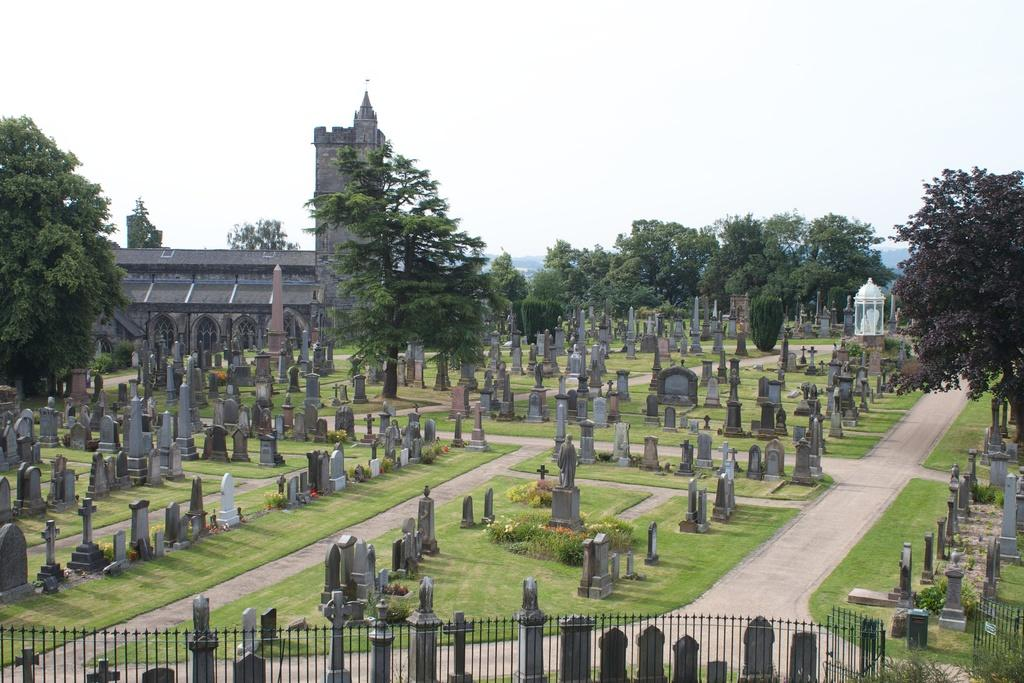What type of structures can be seen in the image? There are gravestones and statues in the image. What type of vegetation is present in the image? There are trees, grass, and plants in the image. What type of boundary is visible in the image? There is a fence in the image. What type of building is present in the image? There is a building in the image. What can be seen in the background of the image? The sky is visible in the background of the image. How many beds are visible in the image? There are no beds present in the image. Is there a boat in the image? There is no boat present in the image. Who is the writer in the image? There is no writer present in the image. 